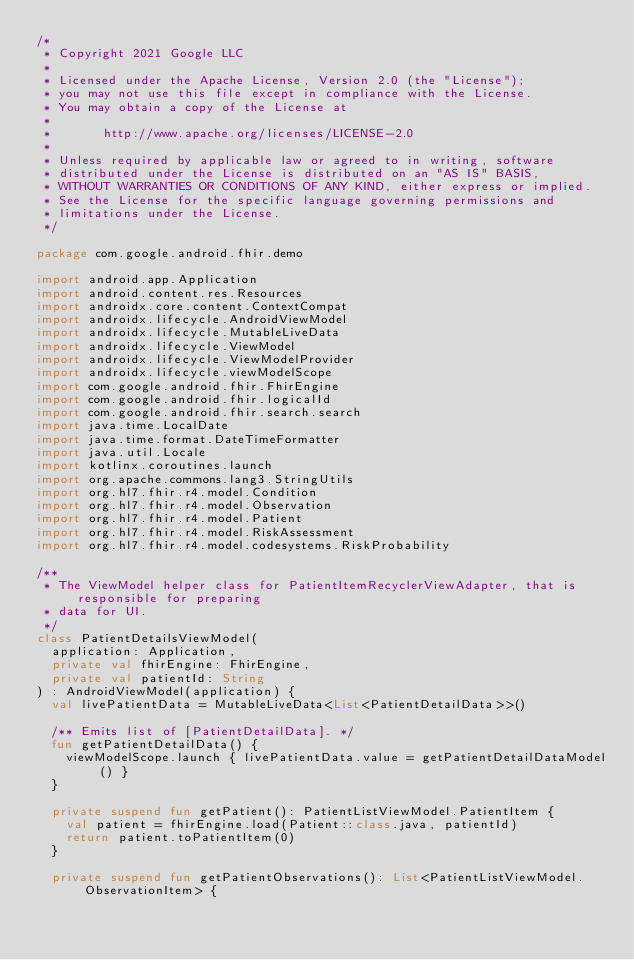Convert code to text. <code><loc_0><loc_0><loc_500><loc_500><_Kotlin_>/*
 * Copyright 2021 Google LLC
 *
 * Licensed under the Apache License, Version 2.0 (the "License");
 * you may not use this file except in compliance with the License.
 * You may obtain a copy of the License at
 *
 *       http://www.apache.org/licenses/LICENSE-2.0
 *
 * Unless required by applicable law or agreed to in writing, software
 * distributed under the License is distributed on an "AS IS" BASIS,
 * WITHOUT WARRANTIES OR CONDITIONS OF ANY KIND, either express or implied.
 * See the License for the specific language governing permissions and
 * limitations under the License.
 */

package com.google.android.fhir.demo

import android.app.Application
import android.content.res.Resources
import androidx.core.content.ContextCompat
import androidx.lifecycle.AndroidViewModel
import androidx.lifecycle.MutableLiveData
import androidx.lifecycle.ViewModel
import androidx.lifecycle.ViewModelProvider
import androidx.lifecycle.viewModelScope
import com.google.android.fhir.FhirEngine
import com.google.android.fhir.logicalId
import com.google.android.fhir.search.search
import java.time.LocalDate
import java.time.format.DateTimeFormatter
import java.util.Locale
import kotlinx.coroutines.launch
import org.apache.commons.lang3.StringUtils
import org.hl7.fhir.r4.model.Condition
import org.hl7.fhir.r4.model.Observation
import org.hl7.fhir.r4.model.Patient
import org.hl7.fhir.r4.model.RiskAssessment
import org.hl7.fhir.r4.model.codesystems.RiskProbability

/**
 * The ViewModel helper class for PatientItemRecyclerViewAdapter, that is responsible for preparing
 * data for UI.
 */
class PatientDetailsViewModel(
  application: Application,
  private val fhirEngine: FhirEngine,
  private val patientId: String
) : AndroidViewModel(application) {
  val livePatientData = MutableLiveData<List<PatientDetailData>>()

  /** Emits list of [PatientDetailData]. */
  fun getPatientDetailData() {
    viewModelScope.launch { livePatientData.value = getPatientDetailDataModel() }
  }

  private suspend fun getPatient(): PatientListViewModel.PatientItem {
    val patient = fhirEngine.load(Patient::class.java, patientId)
    return patient.toPatientItem(0)
  }

  private suspend fun getPatientObservations(): List<PatientListViewModel.ObservationItem> {</code> 